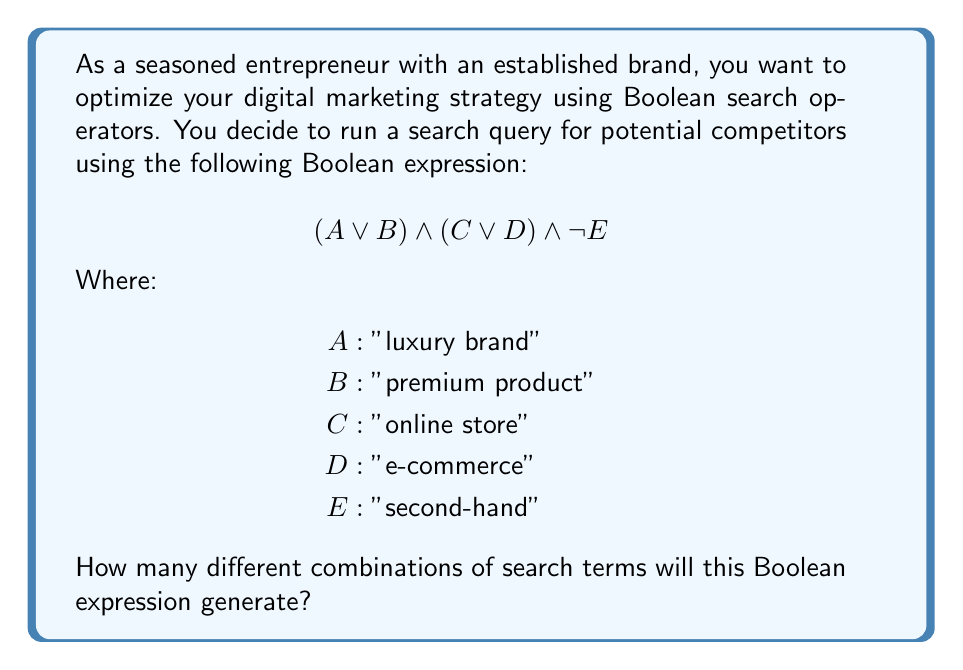Provide a solution to this math problem. Let's approach this step-by-step:

1) First, let's understand what the Boolean expression means:
   $$(A \lor B) \land (C \lor D) \land \lnot E$$
   This expression will include results that have either A or B, AND either C or D, AND not E.

2) We can break this down into two parts:
   $(A \lor B)$ and $(C \lor D)$

3) For $(A \lor B)$, we have 2 possibilities:
   - A is true (B can be either true or false)
   - B is true (A can be either true or false)

4) Similarly, for $(C \lor D)$, we have 2 possibilities:
   - C is true (D can be either true or false)
   - D is true (C can be either true or false)

5) The $\lnot E$ part doesn't add any combinations; it just excludes results with E.

6) To find the total number of combinations, we multiply the number of possibilities from each part:
   $2 \times 2 = 4$

7) These 4 combinations are:
   - A and C (B and D can be either true or false)
   - A and D (B and C can be either true or false)
   - B and C (A and D can be either true or false)
   - B and D (A and C can be either true or false)

Therefore, this Boolean expression will generate 4 different combinations of search terms.
Answer: 4 